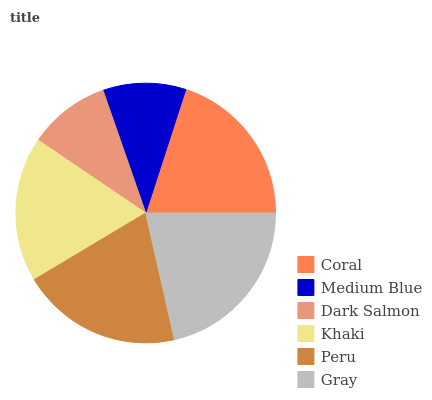Is Dark Salmon the minimum?
Answer yes or no. Yes. Is Gray the maximum?
Answer yes or no. Yes. Is Medium Blue the minimum?
Answer yes or no. No. Is Medium Blue the maximum?
Answer yes or no. No. Is Coral greater than Medium Blue?
Answer yes or no. Yes. Is Medium Blue less than Coral?
Answer yes or no. Yes. Is Medium Blue greater than Coral?
Answer yes or no. No. Is Coral less than Medium Blue?
Answer yes or no. No. Is Peru the high median?
Answer yes or no. Yes. Is Khaki the low median?
Answer yes or no. Yes. Is Gray the high median?
Answer yes or no. No. Is Medium Blue the low median?
Answer yes or no. No. 